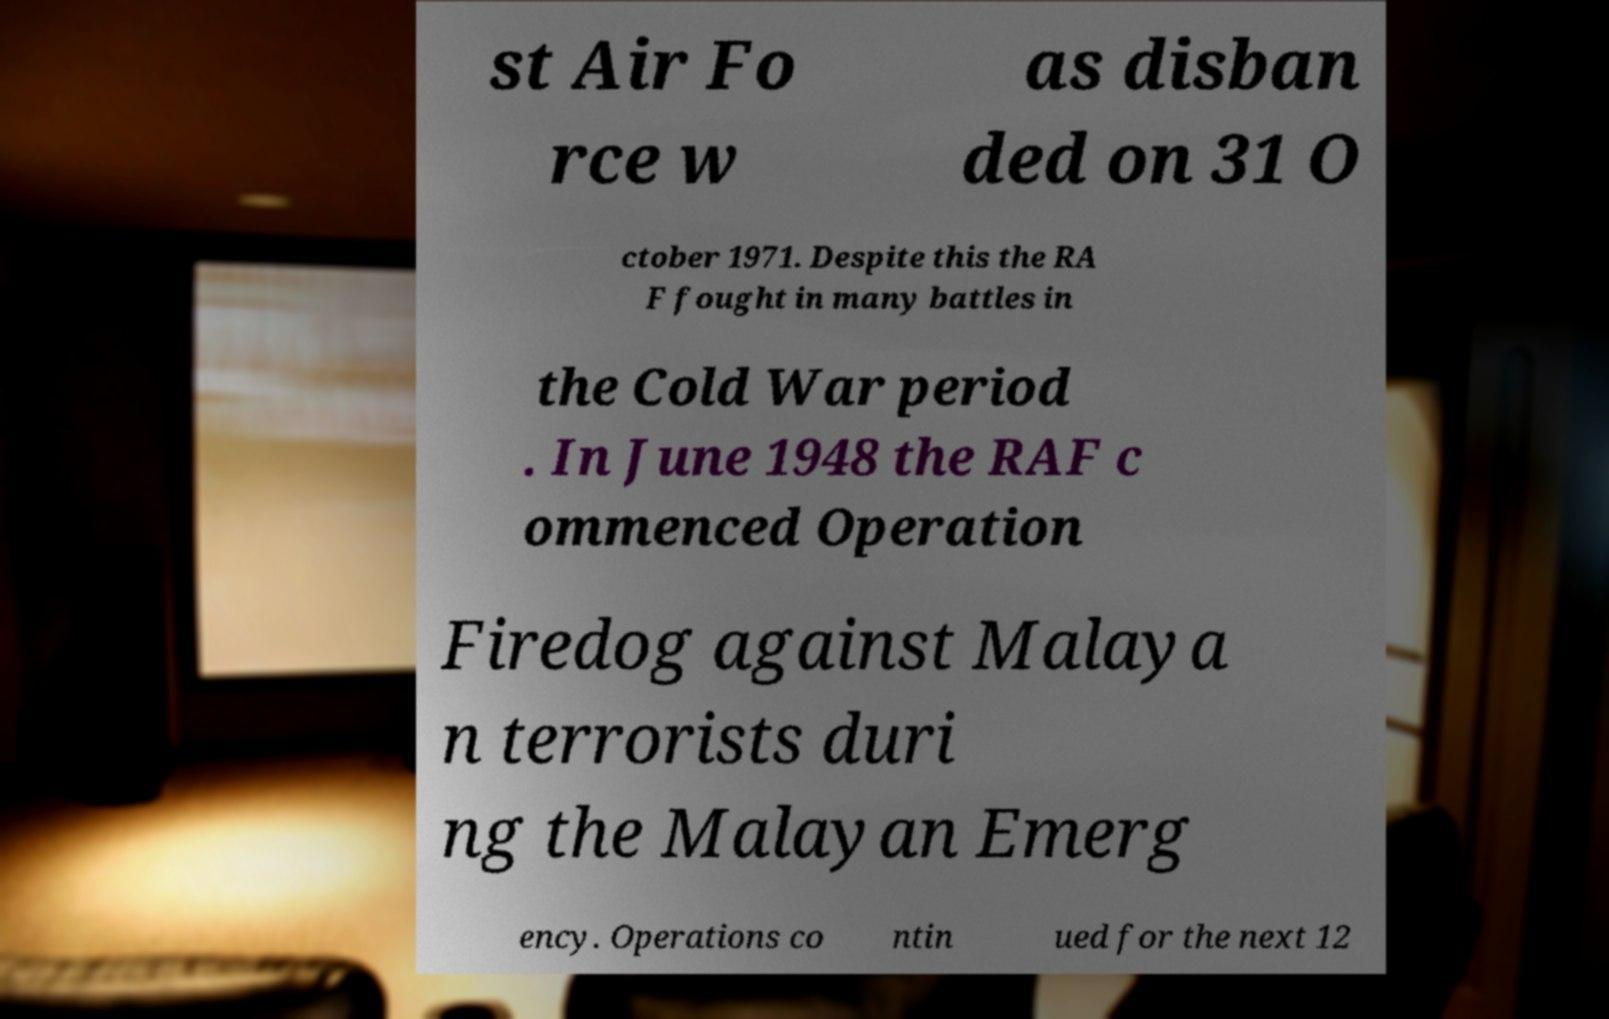Could you assist in decoding the text presented in this image and type it out clearly? st Air Fo rce w as disban ded on 31 O ctober 1971. Despite this the RA F fought in many battles in the Cold War period . In June 1948 the RAF c ommenced Operation Firedog against Malaya n terrorists duri ng the Malayan Emerg ency. Operations co ntin ued for the next 12 